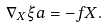Convert formula to latex. <formula><loc_0><loc_0><loc_500><loc_500>\nabla _ { X } \xi a = - f X .</formula> 